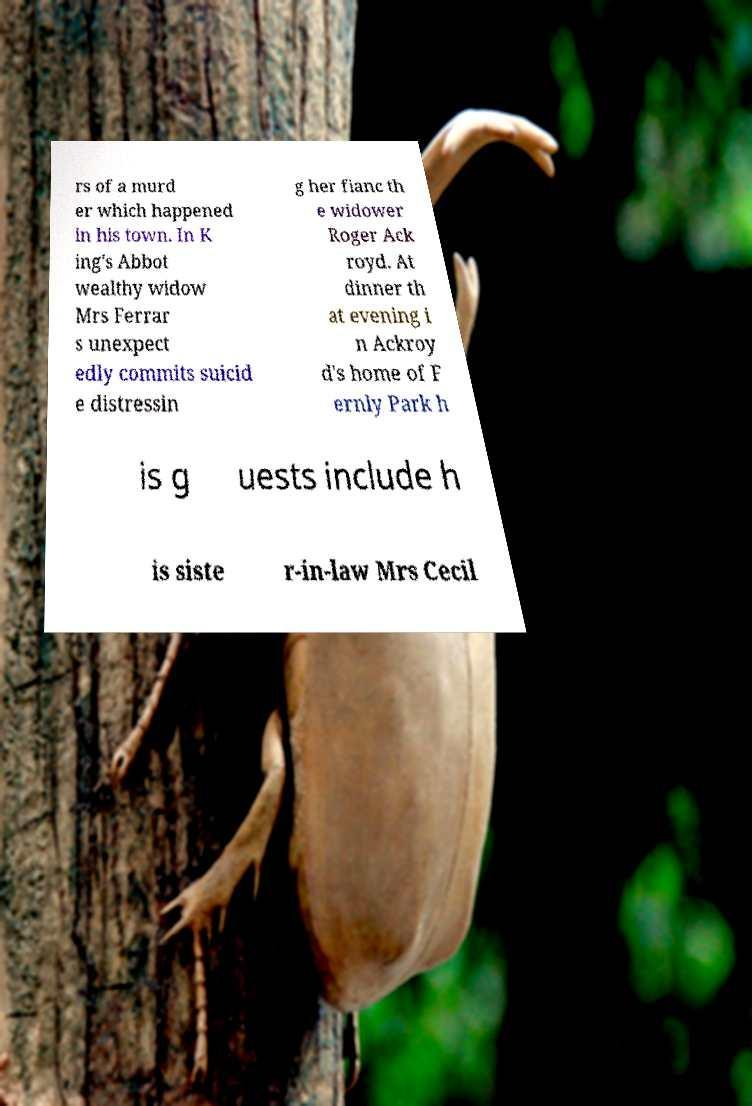For documentation purposes, I need the text within this image transcribed. Could you provide that? rs of a murd er which happened in his town. In K ing's Abbot wealthy widow Mrs Ferrar s unexpect edly commits suicid e distressin g her fianc th e widower Roger Ack royd. At dinner th at evening i n Ackroy d's home of F ernly Park h is g uests include h is siste r-in-law Mrs Cecil 